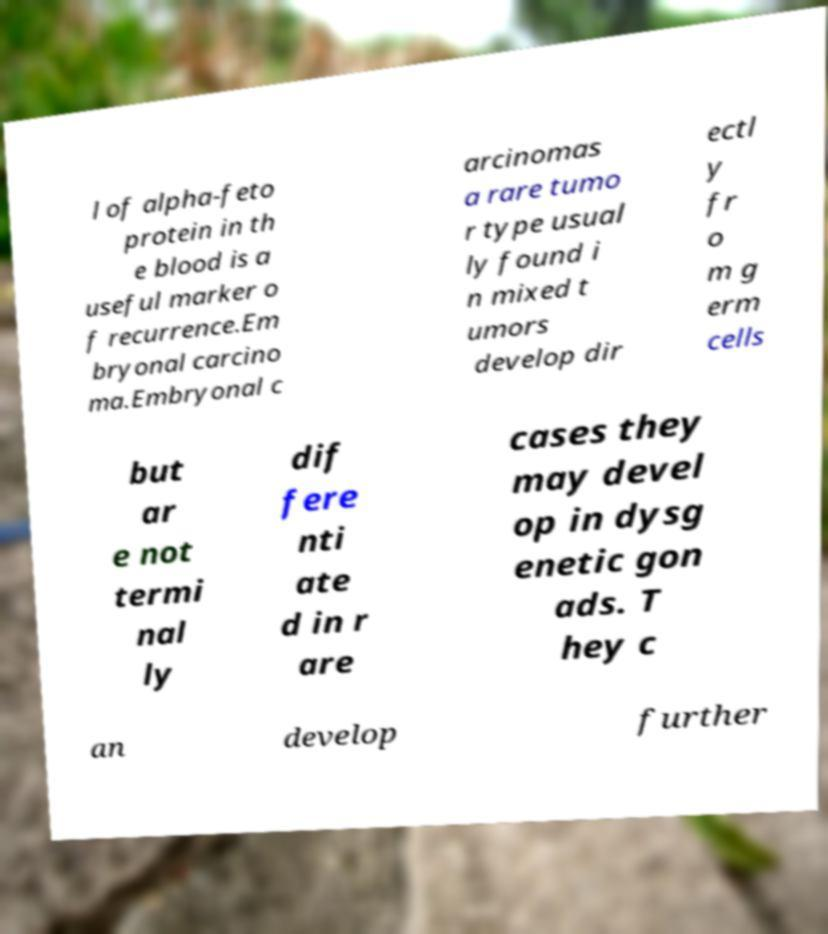Please identify and transcribe the text found in this image. l of alpha-feto protein in th e blood is a useful marker o f recurrence.Em bryonal carcino ma.Embryonal c arcinomas a rare tumo r type usual ly found i n mixed t umors develop dir ectl y fr o m g erm cells but ar e not termi nal ly dif fere nti ate d in r are cases they may devel op in dysg enetic gon ads. T hey c an develop further 